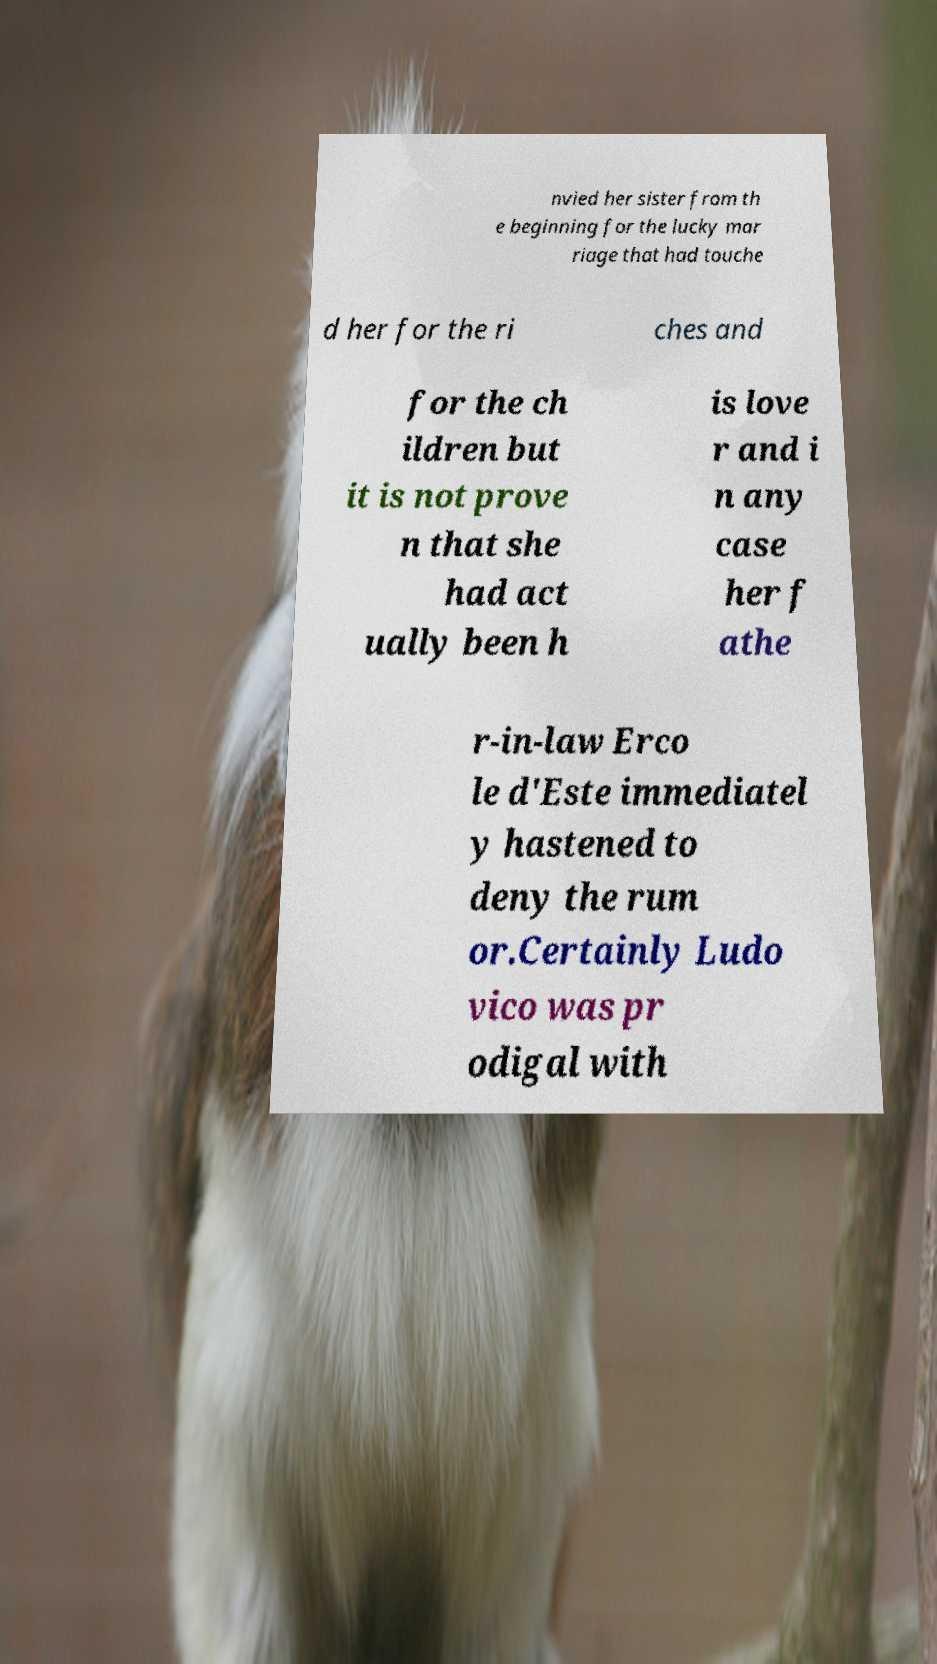Please identify and transcribe the text found in this image. nvied her sister from th e beginning for the lucky mar riage that had touche d her for the ri ches and for the ch ildren but it is not prove n that she had act ually been h is love r and i n any case her f athe r-in-law Erco le d'Este immediatel y hastened to deny the rum or.Certainly Ludo vico was pr odigal with 